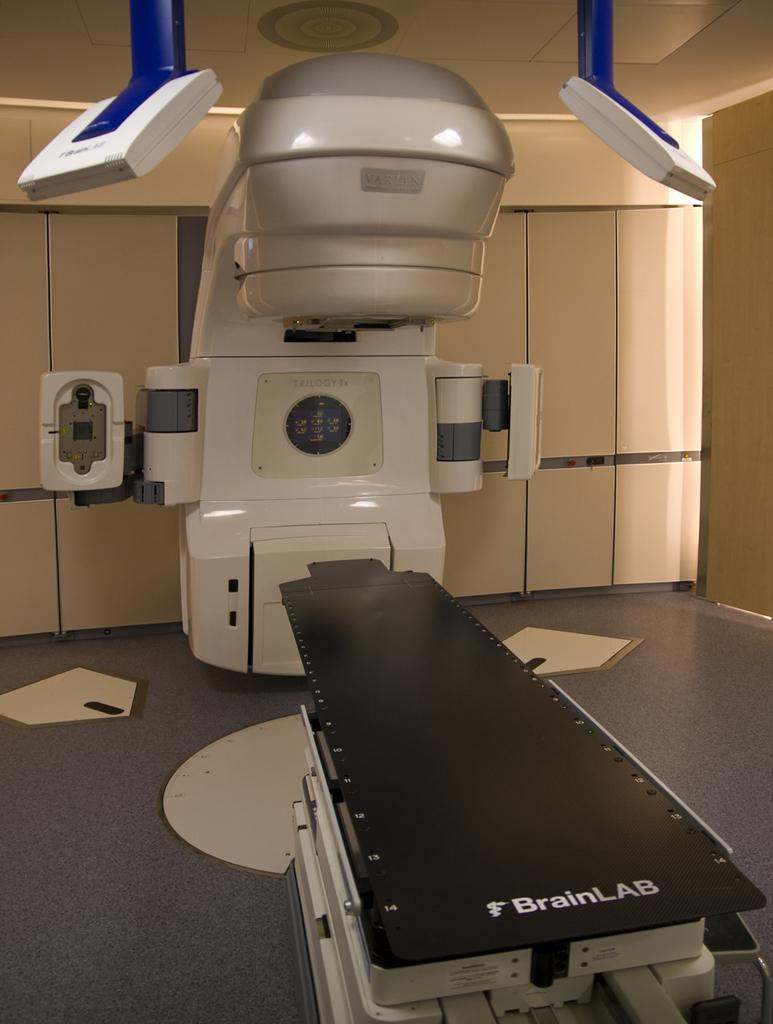What types of objects are present in the image? There are machines in the image. What surface can be seen beneath the machines? There is a floor visible in the image. What separates the space in the image? There is a wall in the image. What type of pet can be seen playing with a fan in the image? There is no pet or fan present in the image. 